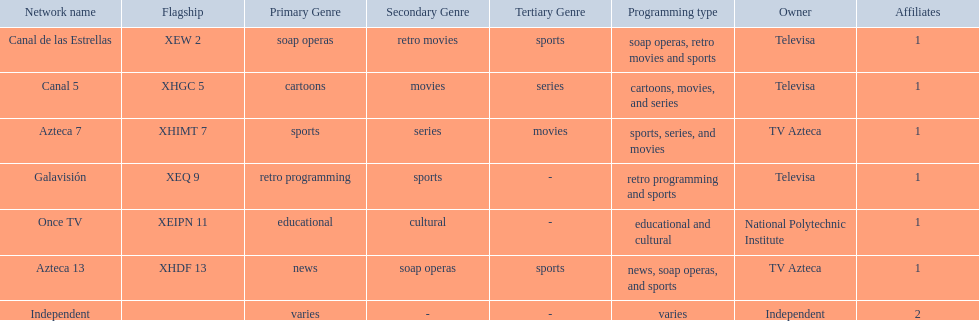What are each of the networks? Canal de las Estrellas, Canal 5, Azteca 7, Galavisión, Once TV, Azteca 13, Independent. Who owns them? Televisa, Televisa, TV Azteca, Televisa, National Polytechnic Institute, TV Azteca, Independent. Which networks aren't owned by televisa? Azteca 7, Once TV, Azteca 13, Independent. What type of programming do those networks offer? Sports, series, and movies, educational and cultural, news, soap operas, and sports, varies. And which network is the only one with sports? Azteca 7. 